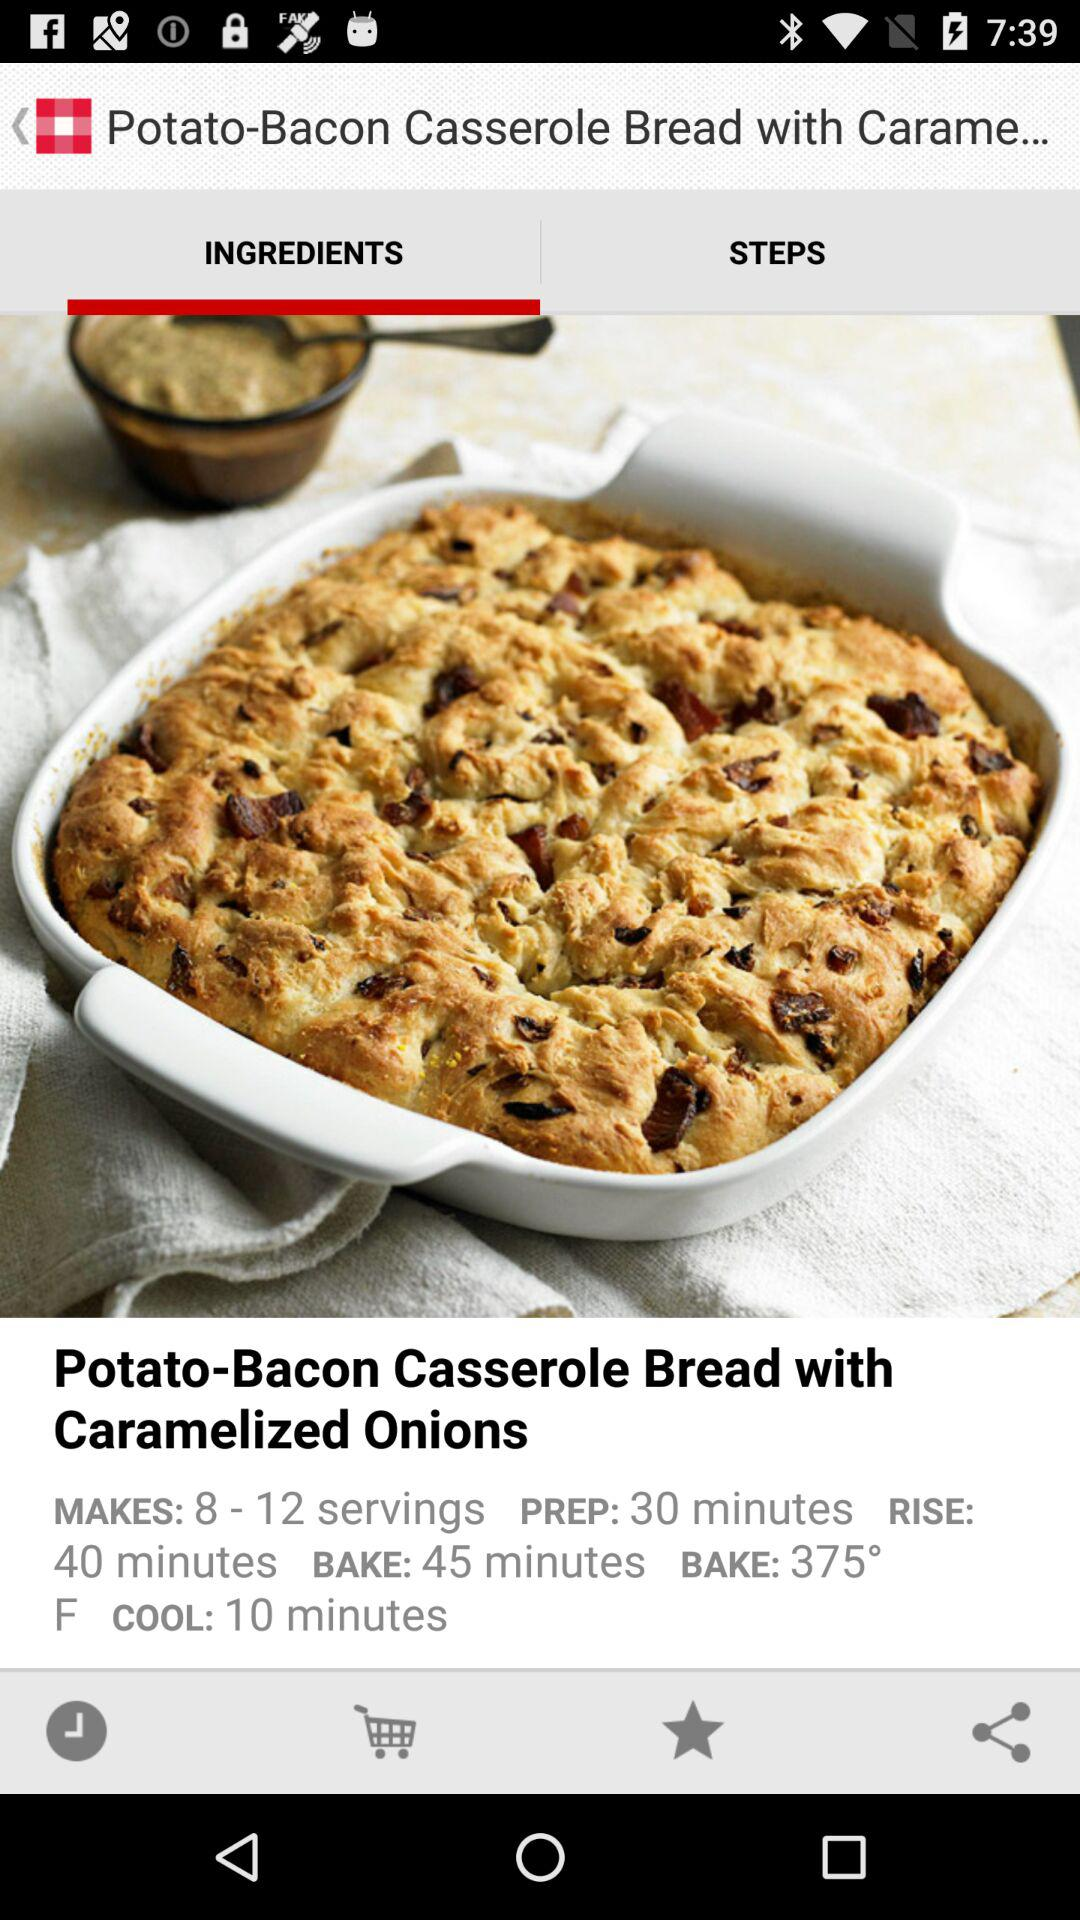At what temperature is this food baked? The food is baked at 375°. 